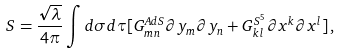Convert formula to latex. <formula><loc_0><loc_0><loc_500><loc_500>S = \frac { \sqrt { \lambda } } { 4 \pi } \int d \sigma d \tau [ G _ { m n } ^ { A d S } \partial y _ { m } \partial y _ { n } + G _ { k l } ^ { S ^ { 5 } } \partial x ^ { k } \partial x ^ { l } ] \, ,</formula> 